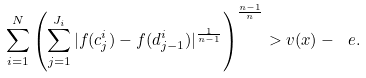<formula> <loc_0><loc_0><loc_500><loc_500>\sum ^ { N } _ { i = 1 } \left ( \sum _ { j = 1 } ^ { J _ { i } } | f ( c ^ { i } _ { j } ) - f ( d ^ { i } _ { j - 1 } ) | ^ { \frac { 1 } { n - 1 } } \right ) ^ { \frac { n - 1 } { n } } > v ( x ) - \ e .</formula> 